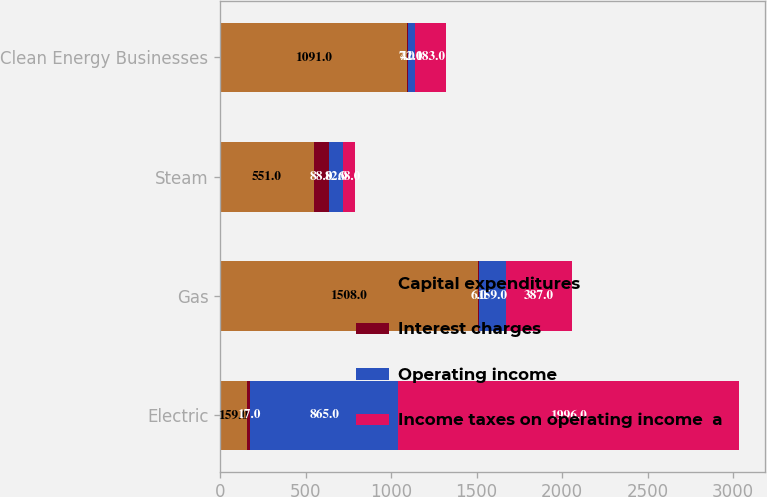Convert chart. <chart><loc_0><loc_0><loc_500><loc_500><stacked_bar_chart><ecel><fcel>Electric<fcel>Gas<fcel>Steam<fcel>Clean Energy Businesses<nl><fcel>Capital expenditures<fcel>159<fcel>1508<fcel>551<fcel>1091<nl><fcel>Interest charges<fcel>17<fcel>6<fcel>88<fcel>7<nl><fcel>Operating income<fcel>865<fcel>159<fcel>82<fcel>42<nl><fcel>Income taxes on operating income  a<fcel>1996<fcel>387<fcel>68<fcel>183<nl></chart> 